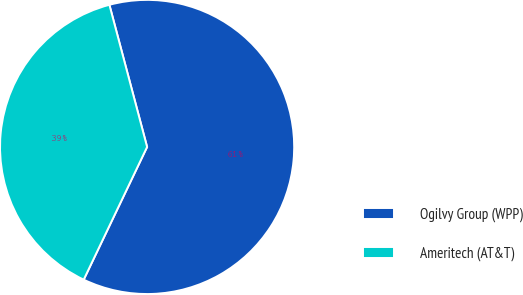Convert chart to OTSL. <chart><loc_0><loc_0><loc_500><loc_500><pie_chart><fcel>Ogilvy Group (WPP)<fcel>Ameritech (AT&T)<nl><fcel>61.22%<fcel>38.78%<nl></chart> 